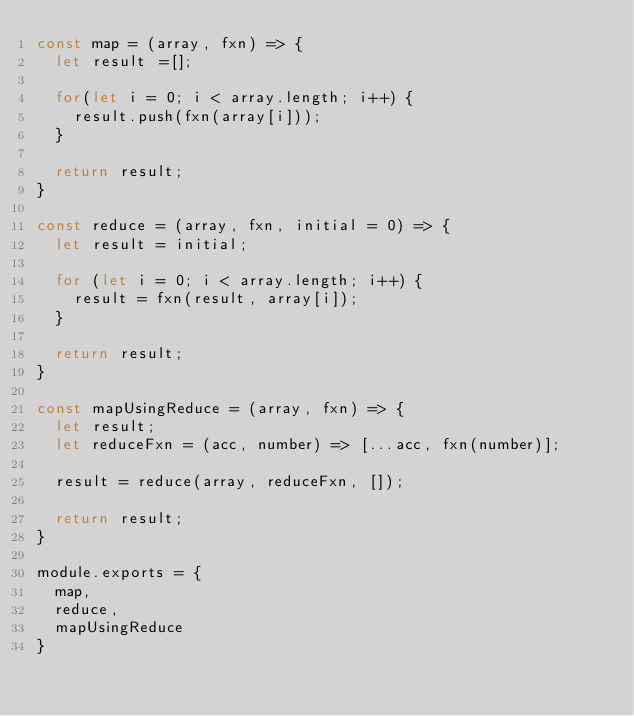Convert code to text. <code><loc_0><loc_0><loc_500><loc_500><_JavaScript_>const map = (array, fxn) => {
  let result =[];

  for(let i = 0; i < array.length; i++) {
    result.push(fxn(array[i]));
  }

  return result;
}

const reduce = (array, fxn, initial = 0) => {
  let result = initial;

  for (let i = 0; i < array.length; i++) {
    result = fxn(result, array[i]);
  }

  return result;
}

const mapUsingReduce = (array, fxn) => {
  let result;
  let reduceFxn = (acc, number) => [...acc, fxn(number)];

  result = reduce(array, reduceFxn, []);

  return result;
}

module.exports = {
  map,
  reduce,
  mapUsingReduce
}
</code> 